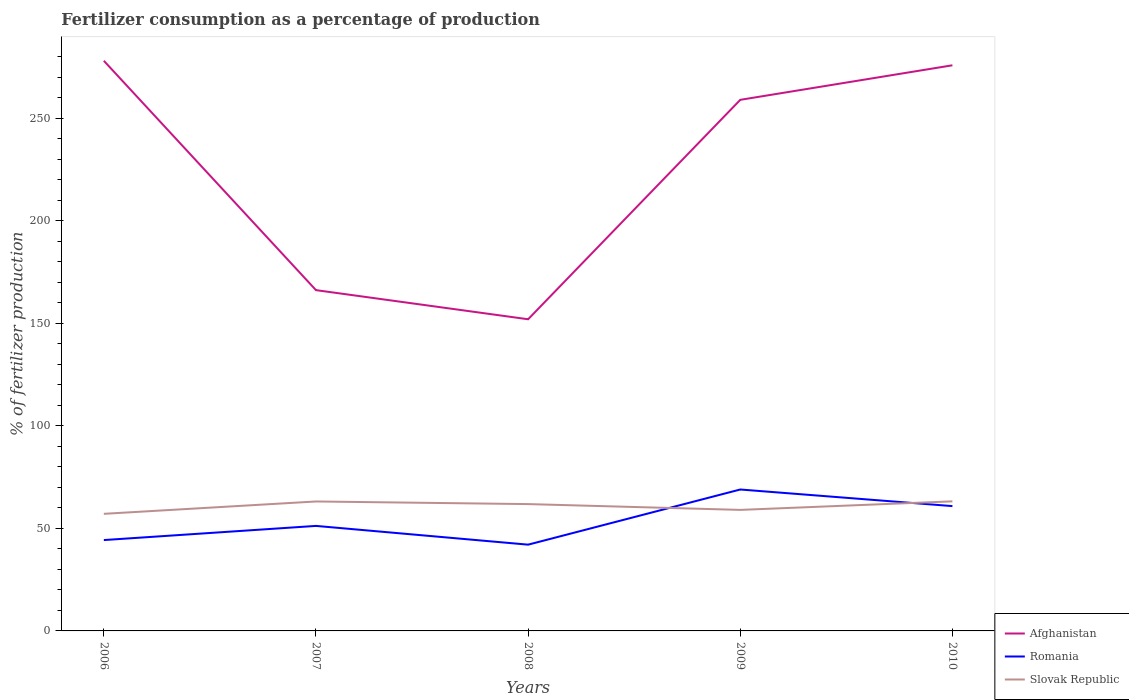Does the line corresponding to Afghanistan intersect with the line corresponding to Romania?
Your answer should be compact. No. Across all years, what is the maximum percentage of fertilizers consumed in Romania?
Offer a terse response. 42.07. In which year was the percentage of fertilizers consumed in Afghanistan maximum?
Your answer should be compact. 2008. What is the total percentage of fertilizers consumed in Romania in the graph?
Provide a succinct answer. -26.89. What is the difference between the highest and the second highest percentage of fertilizers consumed in Slovak Republic?
Offer a terse response. 6.09. What is the difference between the highest and the lowest percentage of fertilizers consumed in Slovak Republic?
Provide a succinct answer. 3. How many years are there in the graph?
Keep it short and to the point. 5. Are the values on the major ticks of Y-axis written in scientific E-notation?
Your answer should be very brief. No. Where does the legend appear in the graph?
Provide a short and direct response. Bottom right. What is the title of the graph?
Your answer should be compact. Fertilizer consumption as a percentage of production. Does "Guinea" appear as one of the legend labels in the graph?
Your response must be concise. No. What is the label or title of the X-axis?
Offer a very short reply. Years. What is the label or title of the Y-axis?
Give a very brief answer. % of fertilizer production. What is the % of fertilizer production in Afghanistan in 2006?
Provide a short and direct response. 278.02. What is the % of fertilizer production in Romania in 2006?
Your response must be concise. 44.3. What is the % of fertilizer production of Slovak Republic in 2006?
Offer a terse response. 57.1. What is the % of fertilizer production of Afghanistan in 2007?
Make the answer very short. 166.18. What is the % of fertilizer production in Romania in 2007?
Keep it short and to the point. 51.21. What is the % of fertilizer production of Slovak Republic in 2007?
Give a very brief answer. 63.13. What is the % of fertilizer production of Afghanistan in 2008?
Your response must be concise. 151.98. What is the % of fertilizer production of Romania in 2008?
Keep it short and to the point. 42.07. What is the % of fertilizer production of Slovak Republic in 2008?
Offer a terse response. 61.84. What is the % of fertilizer production in Afghanistan in 2009?
Provide a short and direct response. 258.97. What is the % of fertilizer production in Romania in 2009?
Ensure brevity in your answer.  68.96. What is the % of fertilizer production of Slovak Republic in 2009?
Provide a short and direct response. 59.02. What is the % of fertilizer production in Afghanistan in 2010?
Your answer should be compact. 275.82. What is the % of fertilizer production of Romania in 2010?
Give a very brief answer. 60.86. What is the % of fertilizer production in Slovak Republic in 2010?
Your answer should be compact. 63.19. Across all years, what is the maximum % of fertilizer production in Afghanistan?
Offer a terse response. 278.02. Across all years, what is the maximum % of fertilizer production in Romania?
Your answer should be compact. 68.96. Across all years, what is the maximum % of fertilizer production of Slovak Republic?
Offer a terse response. 63.19. Across all years, what is the minimum % of fertilizer production in Afghanistan?
Provide a short and direct response. 151.98. Across all years, what is the minimum % of fertilizer production of Romania?
Your response must be concise. 42.07. Across all years, what is the minimum % of fertilizer production in Slovak Republic?
Provide a succinct answer. 57.1. What is the total % of fertilizer production in Afghanistan in the graph?
Offer a very short reply. 1130.97. What is the total % of fertilizer production in Romania in the graph?
Your answer should be very brief. 267.4. What is the total % of fertilizer production in Slovak Republic in the graph?
Offer a terse response. 304.27. What is the difference between the % of fertilizer production in Afghanistan in 2006 and that in 2007?
Your answer should be compact. 111.85. What is the difference between the % of fertilizer production in Romania in 2006 and that in 2007?
Keep it short and to the point. -6.9. What is the difference between the % of fertilizer production of Slovak Republic in 2006 and that in 2007?
Make the answer very short. -6.03. What is the difference between the % of fertilizer production in Afghanistan in 2006 and that in 2008?
Your answer should be compact. 126.04. What is the difference between the % of fertilizer production of Romania in 2006 and that in 2008?
Offer a very short reply. 2.24. What is the difference between the % of fertilizer production in Slovak Republic in 2006 and that in 2008?
Give a very brief answer. -4.75. What is the difference between the % of fertilizer production in Afghanistan in 2006 and that in 2009?
Offer a very short reply. 19.05. What is the difference between the % of fertilizer production of Romania in 2006 and that in 2009?
Offer a terse response. -24.66. What is the difference between the % of fertilizer production in Slovak Republic in 2006 and that in 2009?
Your answer should be very brief. -1.92. What is the difference between the % of fertilizer production in Afghanistan in 2006 and that in 2010?
Your response must be concise. 2.2. What is the difference between the % of fertilizer production of Romania in 2006 and that in 2010?
Keep it short and to the point. -16.56. What is the difference between the % of fertilizer production of Slovak Republic in 2006 and that in 2010?
Offer a terse response. -6.09. What is the difference between the % of fertilizer production of Afghanistan in 2007 and that in 2008?
Offer a terse response. 14.2. What is the difference between the % of fertilizer production in Romania in 2007 and that in 2008?
Give a very brief answer. 9.14. What is the difference between the % of fertilizer production of Slovak Republic in 2007 and that in 2008?
Your response must be concise. 1.28. What is the difference between the % of fertilizer production in Afghanistan in 2007 and that in 2009?
Make the answer very short. -92.8. What is the difference between the % of fertilizer production in Romania in 2007 and that in 2009?
Make the answer very short. -17.75. What is the difference between the % of fertilizer production of Slovak Republic in 2007 and that in 2009?
Offer a terse response. 4.11. What is the difference between the % of fertilizer production in Afghanistan in 2007 and that in 2010?
Keep it short and to the point. -109.64. What is the difference between the % of fertilizer production of Romania in 2007 and that in 2010?
Give a very brief answer. -9.66. What is the difference between the % of fertilizer production of Slovak Republic in 2007 and that in 2010?
Ensure brevity in your answer.  -0.06. What is the difference between the % of fertilizer production in Afghanistan in 2008 and that in 2009?
Your response must be concise. -107. What is the difference between the % of fertilizer production in Romania in 2008 and that in 2009?
Your response must be concise. -26.89. What is the difference between the % of fertilizer production in Slovak Republic in 2008 and that in 2009?
Your answer should be compact. 2.83. What is the difference between the % of fertilizer production in Afghanistan in 2008 and that in 2010?
Offer a terse response. -123.84. What is the difference between the % of fertilizer production of Romania in 2008 and that in 2010?
Offer a terse response. -18.8. What is the difference between the % of fertilizer production of Slovak Republic in 2008 and that in 2010?
Your response must be concise. -1.34. What is the difference between the % of fertilizer production of Afghanistan in 2009 and that in 2010?
Your answer should be compact. -16.85. What is the difference between the % of fertilizer production of Romania in 2009 and that in 2010?
Your answer should be very brief. 8.1. What is the difference between the % of fertilizer production in Slovak Republic in 2009 and that in 2010?
Give a very brief answer. -4.17. What is the difference between the % of fertilizer production of Afghanistan in 2006 and the % of fertilizer production of Romania in 2007?
Give a very brief answer. 226.82. What is the difference between the % of fertilizer production in Afghanistan in 2006 and the % of fertilizer production in Slovak Republic in 2007?
Offer a very short reply. 214.89. What is the difference between the % of fertilizer production in Romania in 2006 and the % of fertilizer production in Slovak Republic in 2007?
Provide a short and direct response. -18.82. What is the difference between the % of fertilizer production of Afghanistan in 2006 and the % of fertilizer production of Romania in 2008?
Give a very brief answer. 235.96. What is the difference between the % of fertilizer production in Afghanistan in 2006 and the % of fertilizer production in Slovak Republic in 2008?
Ensure brevity in your answer.  216.18. What is the difference between the % of fertilizer production in Romania in 2006 and the % of fertilizer production in Slovak Republic in 2008?
Provide a short and direct response. -17.54. What is the difference between the % of fertilizer production in Afghanistan in 2006 and the % of fertilizer production in Romania in 2009?
Your answer should be compact. 209.06. What is the difference between the % of fertilizer production of Afghanistan in 2006 and the % of fertilizer production of Slovak Republic in 2009?
Give a very brief answer. 219.01. What is the difference between the % of fertilizer production of Romania in 2006 and the % of fertilizer production of Slovak Republic in 2009?
Ensure brevity in your answer.  -14.71. What is the difference between the % of fertilizer production in Afghanistan in 2006 and the % of fertilizer production in Romania in 2010?
Offer a very short reply. 217.16. What is the difference between the % of fertilizer production of Afghanistan in 2006 and the % of fertilizer production of Slovak Republic in 2010?
Your response must be concise. 214.83. What is the difference between the % of fertilizer production of Romania in 2006 and the % of fertilizer production of Slovak Republic in 2010?
Your answer should be very brief. -18.88. What is the difference between the % of fertilizer production of Afghanistan in 2007 and the % of fertilizer production of Romania in 2008?
Your response must be concise. 124.11. What is the difference between the % of fertilizer production in Afghanistan in 2007 and the % of fertilizer production in Slovak Republic in 2008?
Your answer should be compact. 104.33. What is the difference between the % of fertilizer production of Romania in 2007 and the % of fertilizer production of Slovak Republic in 2008?
Make the answer very short. -10.64. What is the difference between the % of fertilizer production of Afghanistan in 2007 and the % of fertilizer production of Romania in 2009?
Your answer should be very brief. 97.22. What is the difference between the % of fertilizer production of Afghanistan in 2007 and the % of fertilizer production of Slovak Republic in 2009?
Give a very brief answer. 107.16. What is the difference between the % of fertilizer production of Romania in 2007 and the % of fertilizer production of Slovak Republic in 2009?
Your response must be concise. -7.81. What is the difference between the % of fertilizer production of Afghanistan in 2007 and the % of fertilizer production of Romania in 2010?
Ensure brevity in your answer.  105.31. What is the difference between the % of fertilizer production in Afghanistan in 2007 and the % of fertilizer production in Slovak Republic in 2010?
Offer a terse response. 102.99. What is the difference between the % of fertilizer production of Romania in 2007 and the % of fertilizer production of Slovak Republic in 2010?
Provide a short and direct response. -11.98. What is the difference between the % of fertilizer production of Afghanistan in 2008 and the % of fertilizer production of Romania in 2009?
Keep it short and to the point. 83.02. What is the difference between the % of fertilizer production of Afghanistan in 2008 and the % of fertilizer production of Slovak Republic in 2009?
Ensure brevity in your answer.  92.96. What is the difference between the % of fertilizer production in Romania in 2008 and the % of fertilizer production in Slovak Republic in 2009?
Make the answer very short. -16.95. What is the difference between the % of fertilizer production of Afghanistan in 2008 and the % of fertilizer production of Romania in 2010?
Your answer should be compact. 91.11. What is the difference between the % of fertilizer production in Afghanistan in 2008 and the % of fertilizer production in Slovak Republic in 2010?
Provide a short and direct response. 88.79. What is the difference between the % of fertilizer production of Romania in 2008 and the % of fertilizer production of Slovak Republic in 2010?
Give a very brief answer. -21.12. What is the difference between the % of fertilizer production of Afghanistan in 2009 and the % of fertilizer production of Romania in 2010?
Give a very brief answer. 198.11. What is the difference between the % of fertilizer production of Afghanistan in 2009 and the % of fertilizer production of Slovak Republic in 2010?
Provide a succinct answer. 195.79. What is the difference between the % of fertilizer production of Romania in 2009 and the % of fertilizer production of Slovak Republic in 2010?
Provide a short and direct response. 5.77. What is the average % of fertilizer production of Afghanistan per year?
Offer a terse response. 226.19. What is the average % of fertilizer production in Romania per year?
Ensure brevity in your answer.  53.48. What is the average % of fertilizer production in Slovak Republic per year?
Your answer should be very brief. 60.85. In the year 2006, what is the difference between the % of fertilizer production of Afghanistan and % of fertilizer production of Romania?
Provide a succinct answer. 233.72. In the year 2006, what is the difference between the % of fertilizer production of Afghanistan and % of fertilizer production of Slovak Republic?
Offer a very short reply. 220.92. In the year 2006, what is the difference between the % of fertilizer production in Romania and % of fertilizer production in Slovak Republic?
Your answer should be very brief. -12.8. In the year 2007, what is the difference between the % of fertilizer production in Afghanistan and % of fertilizer production in Romania?
Offer a very short reply. 114.97. In the year 2007, what is the difference between the % of fertilizer production of Afghanistan and % of fertilizer production of Slovak Republic?
Give a very brief answer. 103.05. In the year 2007, what is the difference between the % of fertilizer production in Romania and % of fertilizer production in Slovak Republic?
Provide a short and direct response. -11.92. In the year 2008, what is the difference between the % of fertilizer production of Afghanistan and % of fertilizer production of Romania?
Ensure brevity in your answer.  109.91. In the year 2008, what is the difference between the % of fertilizer production in Afghanistan and % of fertilizer production in Slovak Republic?
Keep it short and to the point. 90.13. In the year 2008, what is the difference between the % of fertilizer production in Romania and % of fertilizer production in Slovak Republic?
Your response must be concise. -19.78. In the year 2009, what is the difference between the % of fertilizer production in Afghanistan and % of fertilizer production in Romania?
Your response must be concise. 190.01. In the year 2009, what is the difference between the % of fertilizer production of Afghanistan and % of fertilizer production of Slovak Republic?
Provide a short and direct response. 199.96. In the year 2009, what is the difference between the % of fertilizer production of Romania and % of fertilizer production of Slovak Republic?
Your response must be concise. 9.94. In the year 2010, what is the difference between the % of fertilizer production in Afghanistan and % of fertilizer production in Romania?
Offer a terse response. 214.96. In the year 2010, what is the difference between the % of fertilizer production in Afghanistan and % of fertilizer production in Slovak Republic?
Provide a succinct answer. 212.63. In the year 2010, what is the difference between the % of fertilizer production in Romania and % of fertilizer production in Slovak Republic?
Give a very brief answer. -2.33. What is the ratio of the % of fertilizer production of Afghanistan in 2006 to that in 2007?
Ensure brevity in your answer.  1.67. What is the ratio of the % of fertilizer production in Romania in 2006 to that in 2007?
Your answer should be very brief. 0.87. What is the ratio of the % of fertilizer production in Slovak Republic in 2006 to that in 2007?
Keep it short and to the point. 0.9. What is the ratio of the % of fertilizer production of Afghanistan in 2006 to that in 2008?
Keep it short and to the point. 1.83. What is the ratio of the % of fertilizer production in Romania in 2006 to that in 2008?
Offer a very short reply. 1.05. What is the ratio of the % of fertilizer production in Slovak Republic in 2006 to that in 2008?
Your answer should be very brief. 0.92. What is the ratio of the % of fertilizer production of Afghanistan in 2006 to that in 2009?
Give a very brief answer. 1.07. What is the ratio of the % of fertilizer production in Romania in 2006 to that in 2009?
Provide a short and direct response. 0.64. What is the ratio of the % of fertilizer production in Slovak Republic in 2006 to that in 2009?
Offer a very short reply. 0.97. What is the ratio of the % of fertilizer production in Afghanistan in 2006 to that in 2010?
Provide a succinct answer. 1.01. What is the ratio of the % of fertilizer production of Romania in 2006 to that in 2010?
Provide a short and direct response. 0.73. What is the ratio of the % of fertilizer production of Slovak Republic in 2006 to that in 2010?
Provide a short and direct response. 0.9. What is the ratio of the % of fertilizer production in Afghanistan in 2007 to that in 2008?
Offer a terse response. 1.09. What is the ratio of the % of fertilizer production of Romania in 2007 to that in 2008?
Your response must be concise. 1.22. What is the ratio of the % of fertilizer production in Slovak Republic in 2007 to that in 2008?
Your response must be concise. 1.02. What is the ratio of the % of fertilizer production in Afghanistan in 2007 to that in 2009?
Your response must be concise. 0.64. What is the ratio of the % of fertilizer production in Romania in 2007 to that in 2009?
Your answer should be compact. 0.74. What is the ratio of the % of fertilizer production of Slovak Republic in 2007 to that in 2009?
Your answer should be compact. 1.07. What is the ratio of the % of fertilizer production in Afghanistan in 2007 to that in 2010?
Keep it short and to the point. 0.6. What is the ratio of the % of fertilizer production of Romania in 2007 to that in 2010?
Offer a very short reply. 0.84. What is the ratio of the % of fertilizer production of Slovak Republic in 2007 to that in 2010?
Keep it short and to the point. 1. What is the ratio of the % of fertilizer production of Afghanistan in 2008 to that in 2009?
Provide a short and direct response. 0.59. What is the ratio of the % of fertilizer production in Romania in 2008 to that in 2009?
Make the answer very short. 0.61. What is the ratio of the % of fertilizer production of Slovak Republic in 2008 to that in 2009?
Ensure brevity in your answer.  1.05. What is the ratio of the % of fertilizer production of Afghanistan in 2008 to that in 2010?
Offer a very short reply. 0.55. What is the ratio of the % of fertilizer production in Romania in 2008 to that in 2010?
Keep it short and to the point. 0.69. What is the ratio of the % of fertilizer production of Slovak Republic in 2008 to that in 2010?
Ensure brevity in your answer.  0.98. What is the ratio of the % of fertilizer production in Afghanistan in 2009 to that in 2010?
Give a very brief answer. 0.94. What is the ratio of the % of fertilizer production of Romania in 2009 to that in 2010?
Your answer should be compact. 1.13. What is the ratio of the % of fertilizer production in Slovak Republic in 2009 to that in 2010?
Your answer should be very brief. 0.93. What is the difference between the highest and the second highest % of fertilizer production of Afghanistan?
Your answer should be compact. 2.2. What is the difference between the highest and the second highest % of fertilizer production in Romania?
Provide a short and direct response. 8.1. What is the difference between the highest and the second highest % of fertilizer production in Slovak Republic?
Make the answer very short. 0.06. What is the difference between the highest and the lowest % of fertilizer production in Afghanistan?
Offer a terse response. 126.04. What is the difference between the highest and the lowest % of fertilizer production in Romania?
Your answer should be compact. 26.89. What is the difference between the highest and the lowest % of fertilizer production of Slovak Republic?
Provide a short and direct response. 6.09. 